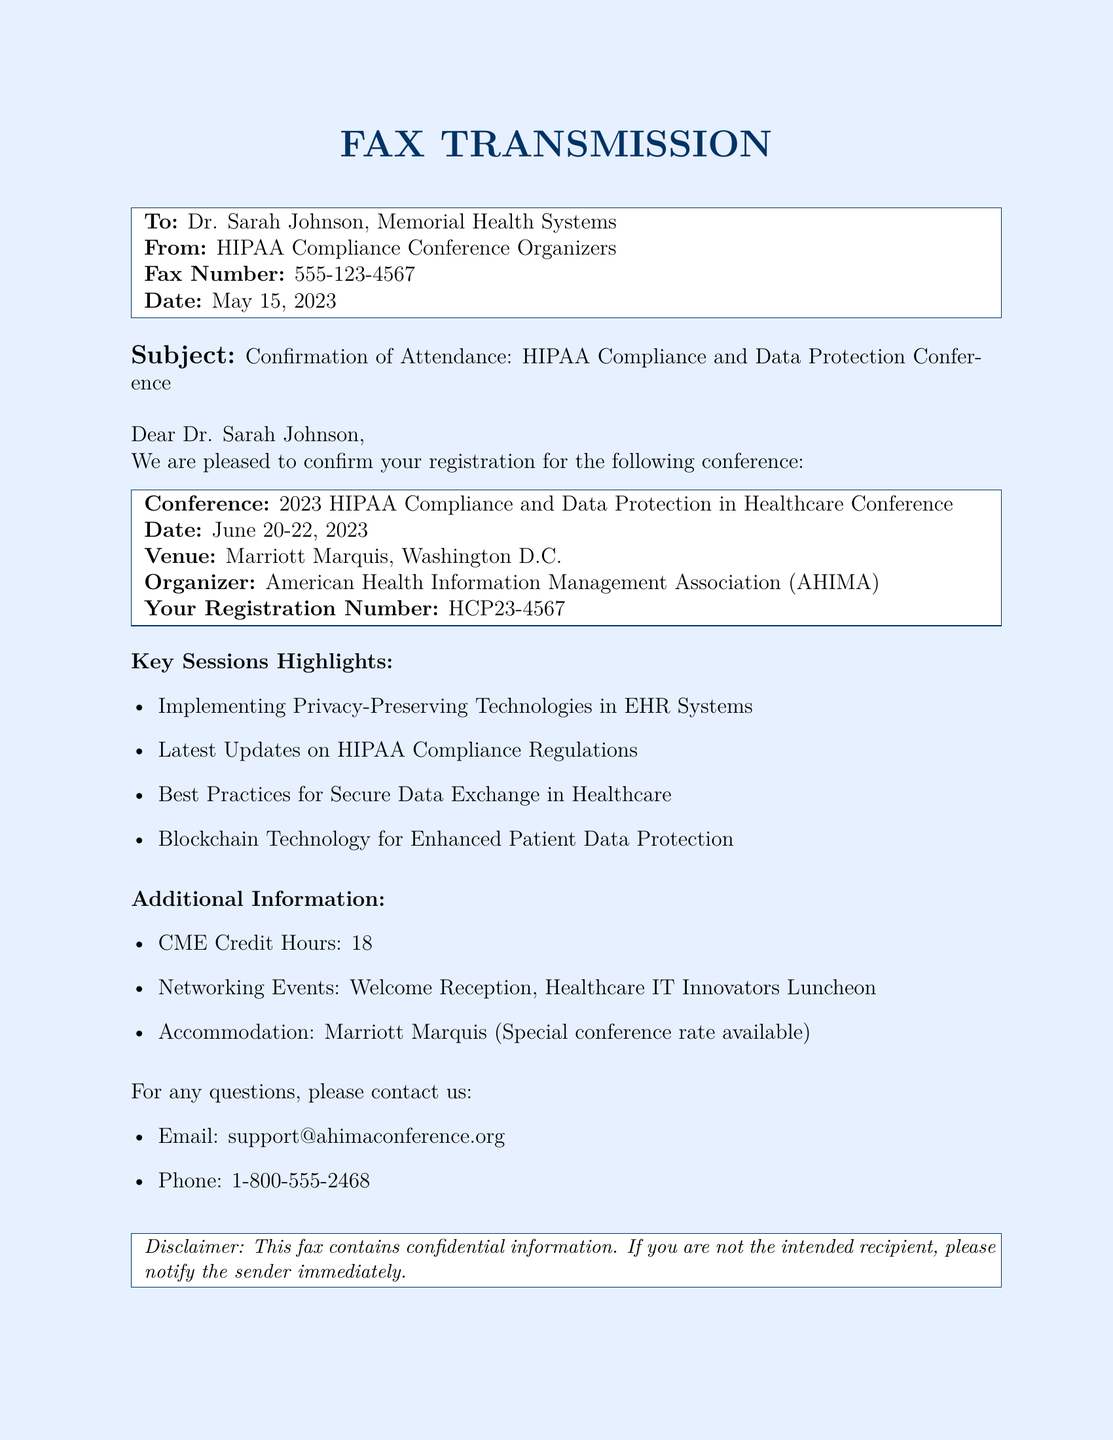What is the conference title? The title of the conference can be found in the document's section about the event.
Answer: 2023 HIPAA Compliance and Data Protection in Healthcare Conference What are the conference dates? The dates are clearly stated in the conference details section of the document.
Answer: June 20-22, 2023 Who is the organizer of the conference? The organizer is mentioned in the details about the conference attendees.
Answer: American Health Information Management Association (AHIMA) How many CME credit hours are available? This information is included in the additional information section of the document.
Answer: 18 What is the registration number? The registration number is provided in the conference details for the attendee.
Answer: HCP23-4567 What type of event will be held for networking? The networking event is highlighted under the additional information section of the fax.
Answer: Welcome Reception What is the venue for the conference? The venue is listed under the conference details section.
Answer: Marriott Marquis, Washington D.C What is the fax number of the recipient? The recipient's fax number is mentioned at the beginning of the document.
Answer: 555-123-4567 What key session focuses on technology for data protection? This session is one of the highlights listed in the document.
Answer: Blockchain Technology for Enhanced Patient Data Protection 